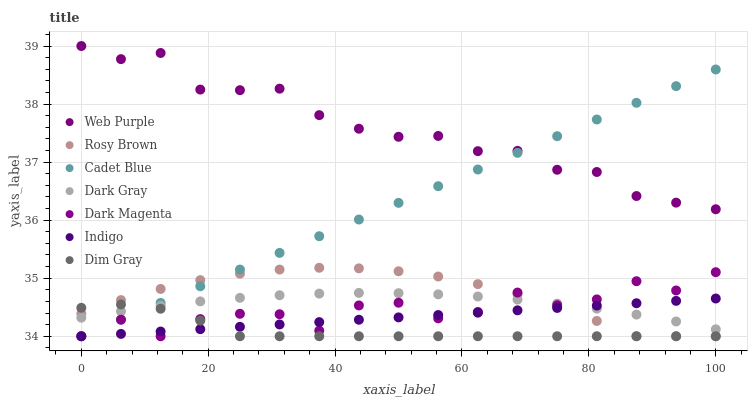Does Dim Gray have the minimum area under the curve?
Answer yes or no. Yes. Does Web Purple have the maximum area under the curve?
Answer yes or no. Yes. Does Indigo have the minimum area under the curve?
Answer yes or no. No. Does Indigo have the maximum area under the curve?
Answer yes or no. No. Is Indigo the smoothest?
Answer yes or no. Yes. Is Dark Magenta the roughest?
Answer yes or no. Yes. Is Dark Magenta the smoothest?
Answer yes or no. No. Is Indigo the roughest?
Answer yes or no. No. Does Cadet Blue have the lowest value?
Answer yes or no. Yes. Does Dark Gray have the lowest value?
Answer yes or no. No. Does Web Purple have the highest value?
Answer yes or no. Yes. Does Indigo have the highest value?
Answer yes or no. No. Is Rosy Brown less than Web Purple?
Answer yes or no. Yes. Is Web Purple greater than Dark Gray?
Answer yes or no. Yes. Does Cadet Blue intersect Indigo?
Answer yes or no. Yes. Is Cadet Blue less than Indigo?
Answer yes or no. No. Is Cadet Blue greater than Indigo?
Answer yes or no. No. Does Rosy Brown intersect Web Purple?
Answer yes or no. No. 